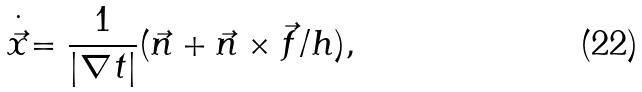<formula> <loc_0><loc_0><loc_500><loc_500>\stackrel { \cdot } { \vec { x } } = \frac { 1 } { | \nabla t | } ( \vec { n } + \vec { n } \times \vec { f } / h ) ,</formula> 